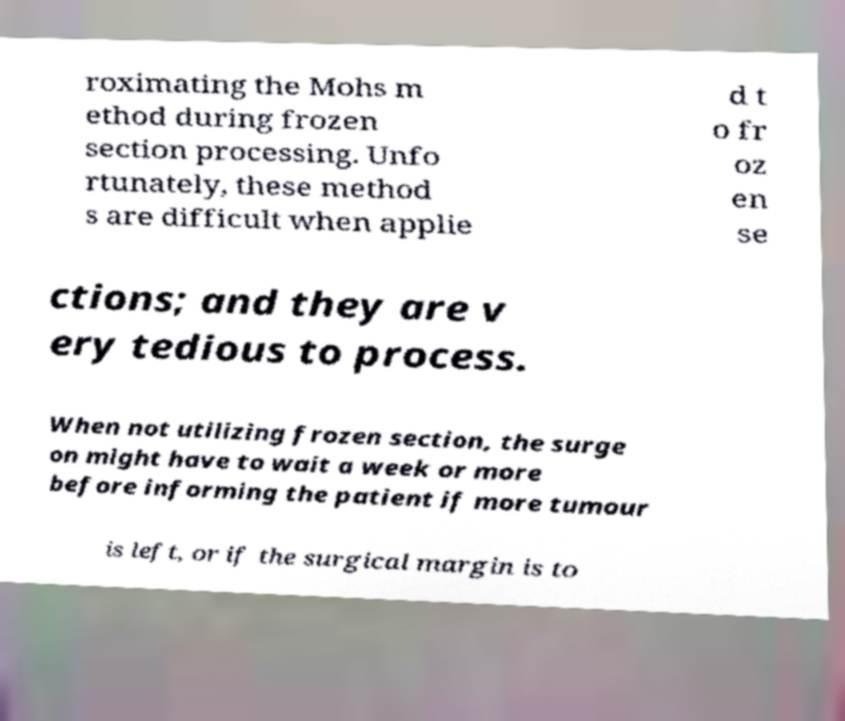What messages or text are displayed in this image? I need them in a readable, typed format. roximating the Mohs m ethod during frozen section processing. Unfo rtunately, these method s are difficult when applie d t o fr oz en se ctions; and they are v ery tedious to process. When not utilizing frozen section, the surge on might have to wait a week or more before informing the patient if more tumour is left, or if the surgical margin is to 